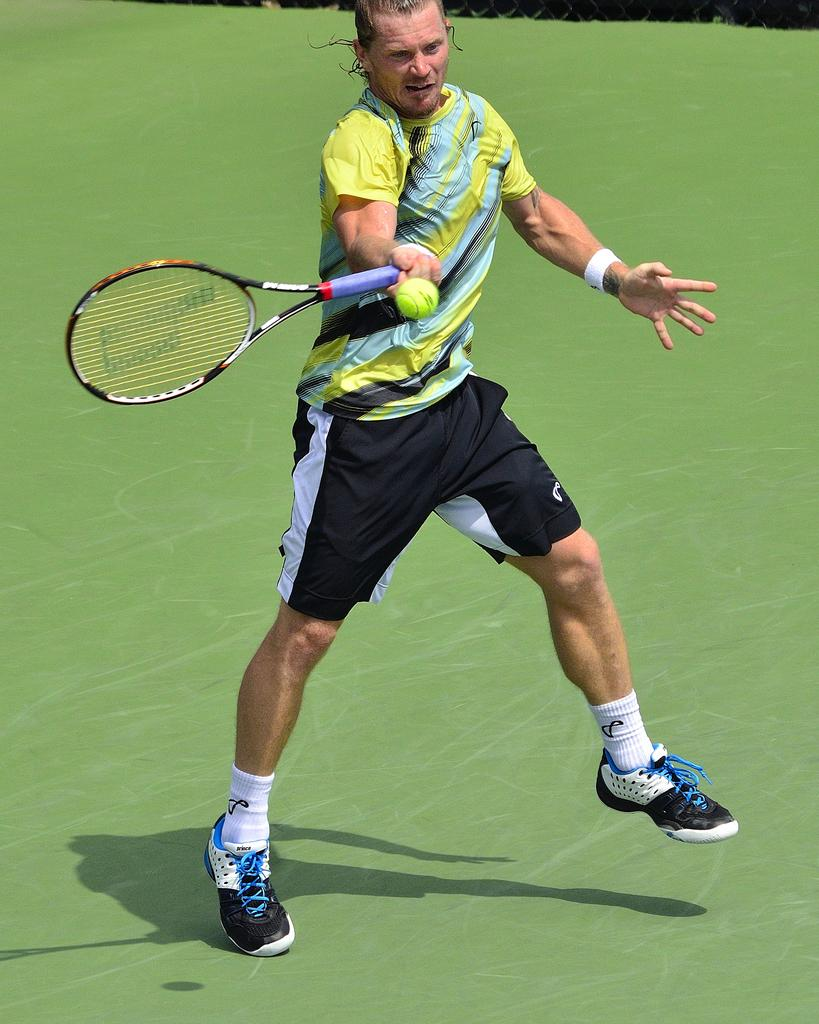How many people are in the image? There are persons in the image, but the exact number is not specified. What are the persons wearing? The persons are wearing clothes. What objects are the persons holding? The persons are holding tennis rackets. What is in the middle of the image? There is a ball in the middle of the image. What type of stone is being used as a meal in the image? There is no stone or meal present in the image; it features persons holding tennis rackets and a ball in the middle. 